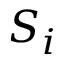Convert formula to latex. <formula><loc_0><loc_0><loc_500><loc_500>S _ { i }</formula> 